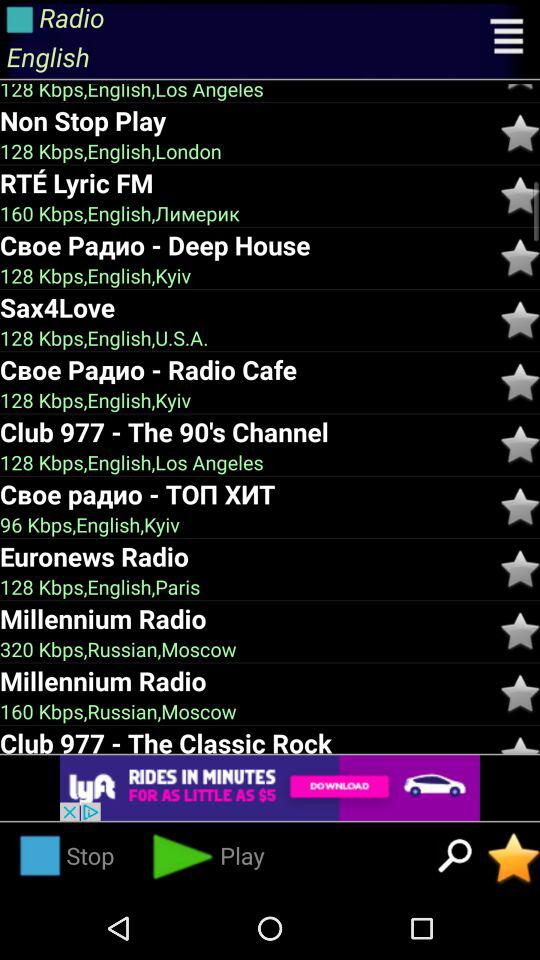What's the data transfer speed of Euronews Radio?
When the provided information is insufficient, respond with <no answer>. <no answer> 